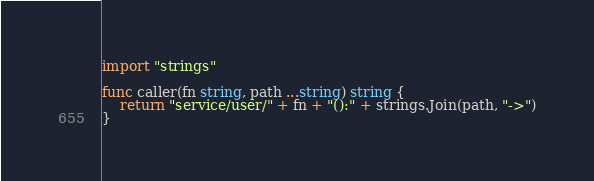<code> <loc_0><loc_0><loc_500><loc_500><_Go_>import "strings"

func caller(fn string, path ...string) string {
	return "service/user/" + fn + "():" + strings.Join(path, "->")
}
</code> 